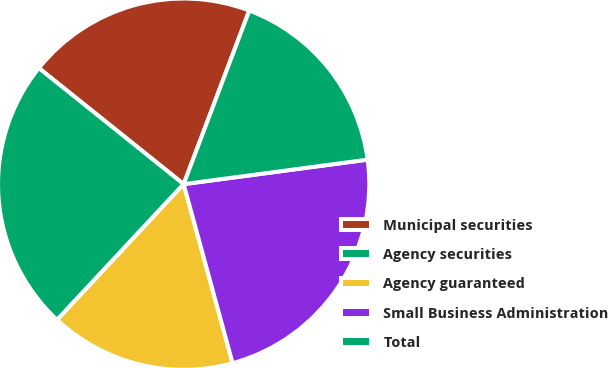Convert chart to OTSL. <chart><loc_0><loc_0><loc_500><loc_500><pie_chart><fcel>Municipal securities<fcel>Agency securities<fcel>Agency guaranteed<fcel>Small Business Administration<fcel>Total<nl><fcel>20.0%<fcel>23.81%<fcel>16.19%<fcel>22.86%<fcel>17.14%<nl></chart> 